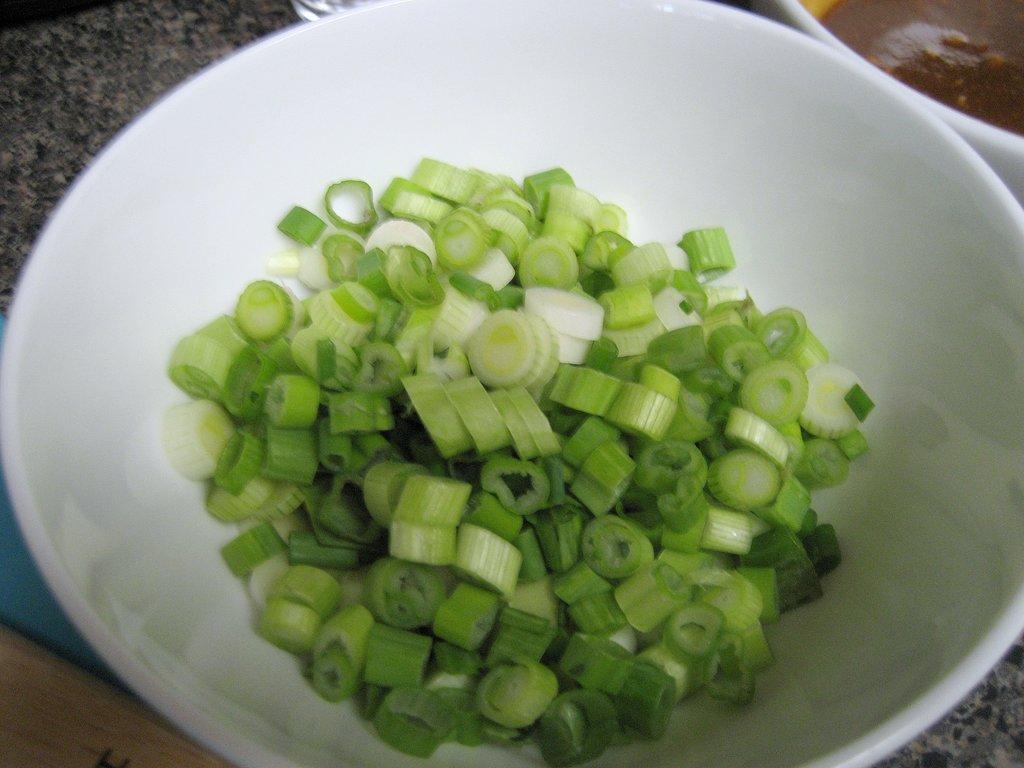Describe this image in one or two sentences. In this image I can see a white colour bowl and in it I can see chopped spring onions. On the top right side of this image I can see one more bowl and in it I can see brown colour thing. 